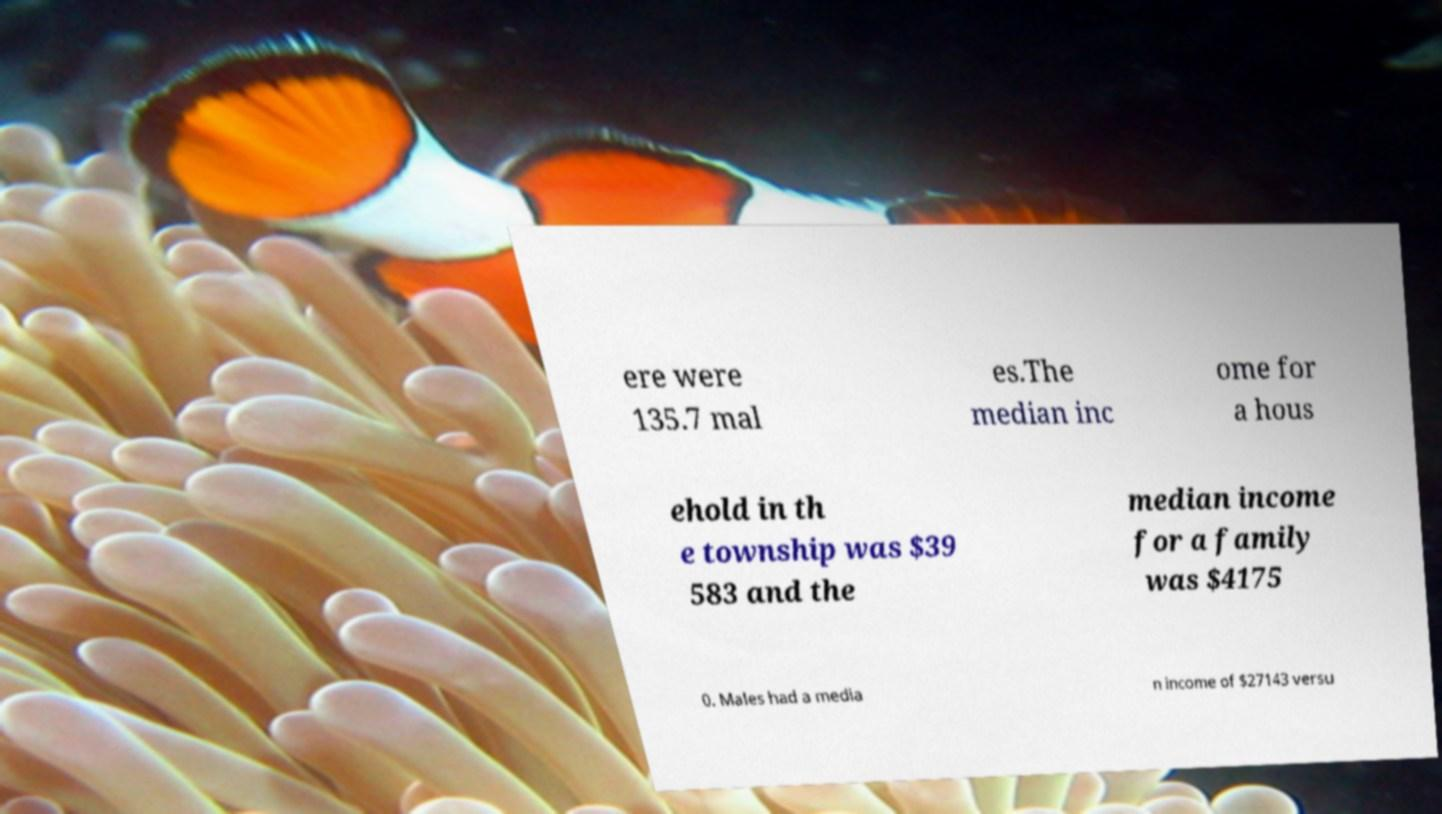Could you extract and type out the text from this image? ere were 135.7 mal es.The median inc ome for a hous ehold in th e township was $39 583 and the median income for a family was $4175 0. Males had a media n income of $27143 versu 